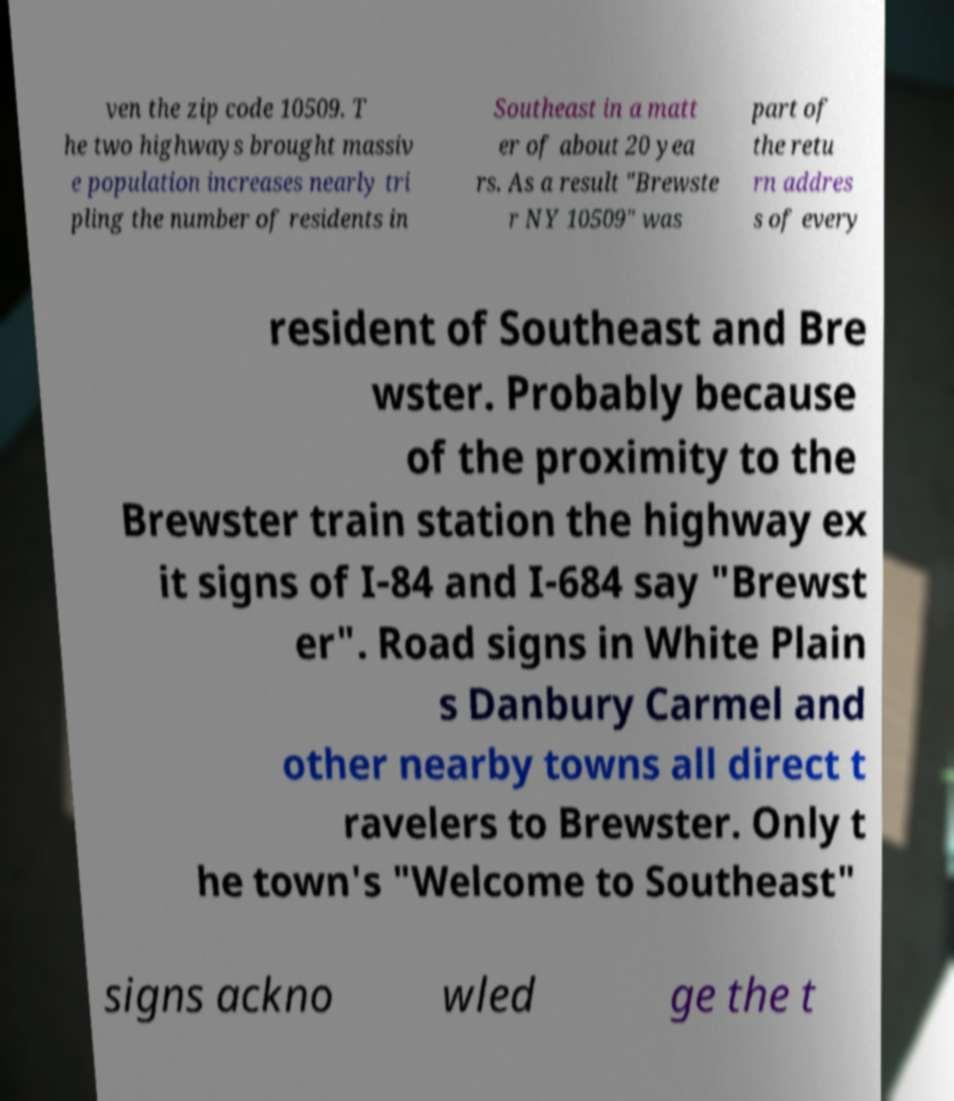Could you assist in decoding the text presented in this image and type it out clearly? ven the zip code 10509. T he two highways brought massiv e population increases nearly tri pling the number of residents in Southeast in a matt er of about 20 yea rs. As a result "Brewste r NY 10509" was part of the retu rn addres s of every resident of Southeast and Bre wster. Probably because of the proximity to the Brewster train station the highway ex it signs of I-84 and I-684 say "Brewst er". Road signs in White Plain s Danbury Carmel and other nearby towns all direct t ravelers to Brewster. Only t he town's "Welcome to Southeast" signs ackno wled ge the t 